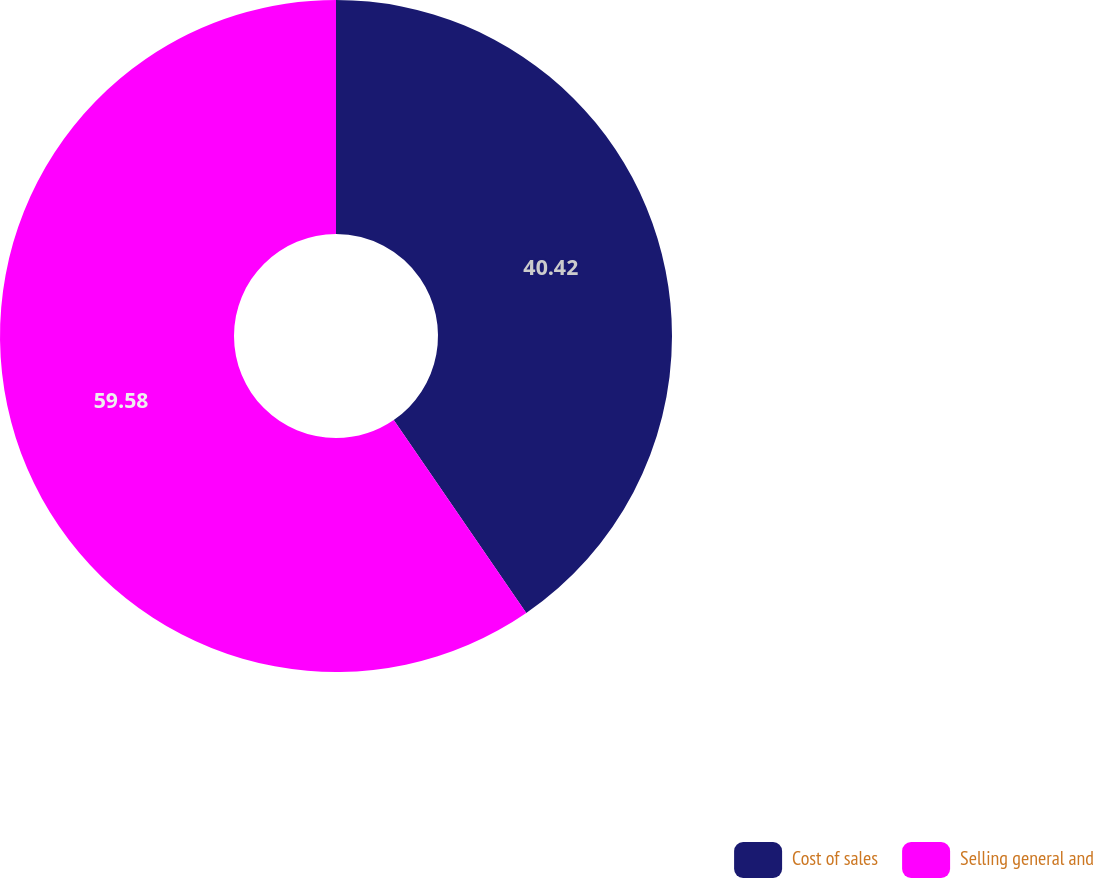Convert chart. <chart><loc_0><loc_0><loc_500><loc_500><pie_chart><fcel>Cost of sales<fcel>Selling general and<nl><fcel>40.42%<fcel>59.58%<nl></chart> 